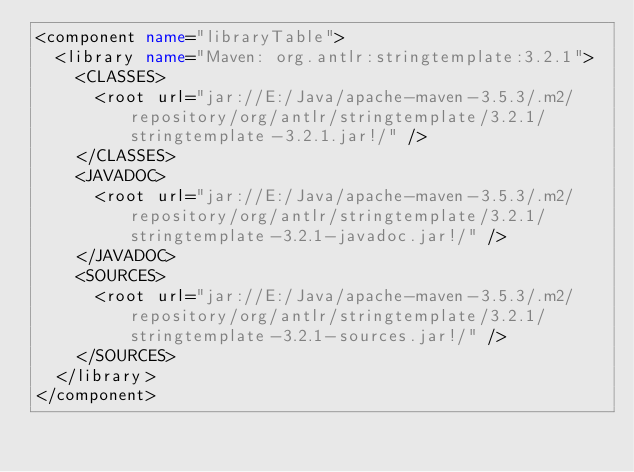<code> <loc_0><loc_0><loc_500><loc_500><_XML_><component name="libraryTable">
  <library name="Maven: org.antlr:stringtemplate:3.2.1">
    <CLASSES>
      <root url="jar://E:/Java/apache-maven-3.5.3/.m2/repository/org/antlr/stringtemplate/3.2.1/stringtemplate-3.2.1.jar!/" />
    </CLASSES>
    <JAVADOC>
      <root url="jar://E:/Java/apache-maven-3.5.3/.m2/repository/org/antlr/stringtemplate/3.2.1/stringtemplate-3.2.1-javadoc.jar!/" />
    </JAVADOC>
    <SOURCES>
      <root url="jar://E:/Java/apache-maven-3.5.3/.m2/repository/org/antlr/stringtemplate/3.2.1/stringtemplate-3.2.1-sources.jar!/" />
    </SOURCES>
  </library>
</component></code> 